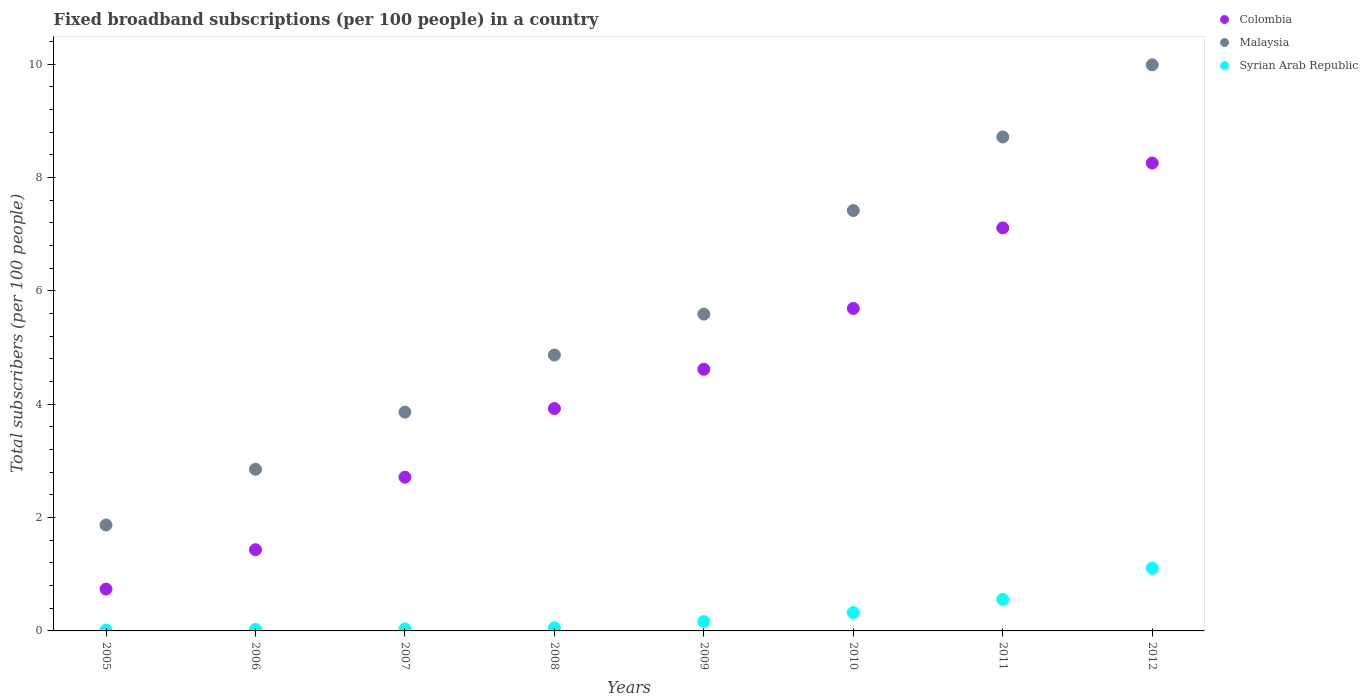How many different coloured dotlines are there?
Make the answer very short. 3. Is the number of dotlines equal to the number of legend labels?
Ensure brevity in your answer.  Yes. What is the number of broadband subscriptions in Syrian Arab Republic in 2011?
Keep it short and to the point. 0.56. Across all years, what is the maximum number of broadband subscriptions in Colombia?
Offer a very short reply. 8.26. Across all years, what is the minimum number of broadband subscriptions in Malaysia?
Make the answer very short. 1.87. In which year was the number of broadband subscriptions in Colombia maximum?
Make the answer very short. 2012. In which year was the number of broadband subscriptions in Syrian Arab Republic minimum?
Provide a succinct answer. 2005. What is the total number of broadband subscriptions in Colombia in the graph?
Offer a very short reply. 34.48. What is the difference between the number of broadband subscriptions in Malaysia in 2007 and that in 2008?
Your response must be concise. -1.01. What is the difference between the number of broadband subscriptions in Colombia in 2009 and the number of broadband subscriptions in Syrian Arab Republic in 2012?
Give a very brief answer. 3.51. What is the average number of broadband subscriptions in Syrian Arab Republic per year?
Offer a very short reply. 0.29. In the year 2007, what is the difference between the number of broadband subscriptions in Colombia and number of broadband subscriptions in Malaysia?
Your answer should be compact. -1.15. In how many years, is the number of broadband subscriptions in Syrian Arab Republic greater than 2.8?
Provide a succinct answer. 0. What is the ratio of the number of broadband subscriptions in Malaysia in 2009 to that in 2012?
Provide a short and direct response. 0.56. Is the number of broadband subscriptions in Colombia in 2007 less than that in 2012?
Ensure brevity in your answer.  Yes. Is the difference between the number of broadband subscriptions in Colombia in 2008 and 2010 greater than the difference between the number of broadband subscriptions in Malaysia in 2008 and 2010?
Provide a short and direct response. Yes. What is the difference between the highest and the second highest number of broadband subscriptions in Syrian Arab Republic?
Your answer should be compact. 0.55. What is the difference between the highest and the lowest number of broadband subscriptions in Syrian Arab Republic?
Keep it short and to the point. 1.09. In how many years, is the number of broadband subscriptions in Colombia greater than the average number of broadband subscriptions in Colombia taken over all years?
Your answer should be very brief. 4. How many years are there in the graph?
Make the answer very short. 8. What is the difference between two consecutive major ticks on the Y-axis?
Offer a terse response. 2. Are the values on the major ticks of Y-axis written in scientific E-notation?
Your answer should be compact. No. Does the graph contain grids?
Provide a succinct answer. No. How are the legend labels stacked?
Give a very brief answer. Vertical. What is the title of the graph?
Your answer should be compact. Fixed broadband subscriptions (per 100 people) in a country. Does "Uzbekistan" appear as one of the legend labels in the graph?
Keep it short and to the point. No. What is the label or title of the X-axis?
Offer a terse response. Years. What is the label or title of the Y-axis?
Give a very brief answer. Total subscribers (per 100 people). What is the Total subscribers (per 100 people) of Colombia in 2005?
Provide a short and direct response. 0.74. What is the Total subscribers (per 100 people) in Malaysia in 2005?
Ensure brevity in your answer.  1.87. What is the Total subscribers (per 100 people) of Syrian Arab Republic in 2005?
Your answer should be very brief. 0.01. What is the Total subscribers (per 100 people) in Colombia in 2006?
Your answer should be very brief. 1.43. What is the Total subscribers (per 100 people) of Malaysia in 2006?
Your answer should be very brief. 2.85. What is the Total subscribers (per 100 people) in Syrian Arab Republic in 2006?
Make the answer very short. 0.03. What is the Total subscribers (per 100 people) of Colombia in 2007?
Provide a short and direct response. 2.71. What is the Total subscribers (per 100 people) of Malaysia in 2007?
Your answer should be compact. 3.86. What is the Total subscribers (per 100 people) of Syrian Arab Republic in 2007?
Provide a succinct answer. 0.04. What is the Total subscribers (per 100 people) of Colombia in 2008?
Offer a terse response. 3.92. What is the Total subscribers (per 100 people) in Malaysia in 2008?
Your answer should be compact. 4.87. What is the Total subscribers (per 100 people) of Syrian Arab Republic in 2008?
Your answer should be very brief. 0.05. What is the Total subscribers (per 100 people) in Colombia in 2009?
Your response must be concise. 4.62. What is the Total subscribers (per 100 people) of Malaysia in 2009?
Provide a succinct answer. 5.59. What is the Total subscribers (per 100 people) in Syrian Arab Republic in 2009?
Provide a succinct answer. 0.16. What is the Total subscribers (per 100 people) of Colombia in 2010?
Ensure brevity in your answer.  5.69. What is the Total subscribers (per 100 people) of Malaysia in 2010?
Your answer should be very brief. 7.42. What is the Total subscribers (per 100 people) in Syrian Arab Republic in 2010?
Give a very brief answer. 0.32. What is the Total subscribers (per 100 people) of Colombia in 2011?
Your answer should be compact. 7.11. What is the Total subscribers (per 100 people) of Malaysia in 2011?
Provide a short and direct response. 8.72. What is the Total subscribers (per 100 people) of Syrian Arab Republic in 2011?
Your answer should be very brief. 0.56. What is the Total subscribers (per 100 people) of Colombia in 2012?
Your response must be concise. 8.26. What is the Total subscribers (per 100 people) in Malaysia in 2012?
Provide a succinct answer. 9.99. What is the Total subscribers (per 100 people) of Syrian Arab Republic in 2012?
Provide a succinct answer. 1.11. Across all years, what is the maximum Total subscribers (per 100 people) of Colombia?
Offer a very short reply. 8.26. Across all years, what is the maximum Total subscribers (per 100 people) in Malaysia?
Your answer should be very brief. 9.99. Across all years, what is the maximum Total subscribers (per 100 people) of Syrian Arab Republic?
Your answer should be compact. 1.11. Across all years, what is the minimum Total subscribers (per 100 people) in Colombia?
Ensure brevity in your answer.  0.74. Across all years, what is the minimum Total subscribers (per 100 people) in Malaysia?
Your answer should be compact. 1.87. Across all years, what is the minimum Total subscribers (per 100 people) in Syrian Arab Republic?
Your response must be concise. 0.01. What is the total Total subscribers (per 100 people) in Colombia in the graph?
Your answer should be very brief. 34.48. What is the total Total subscribers (per 100 people) in Malaysia in the graph?
Provide a short and direct response. 45.17. What is the total Total subscribers (per 100 people) of Syrian Arab Republic in the graph?
Make the answer very short. 2.28. What is the difference between the Total subscribers (per 100 people) in Colombia in 2005 and that in 2006?
Your response must be concise. -0.69. What is the difference between the Total subscribers (per 100 people) of Malaysia in 2005 and that in 2006?
Your answer should be very brief. -0.98. What is the difference between the Total subscribers (per 100 people) of Syrian Arab Republic in 2005 and that in 2006?
Your answer should be very brief. -0.01. What is the difference between the Total subscribers (per 100 people) in Colombia in 2005 and that in 2007?
Provide a short and direct response. -1.97. What is the difference between the Total subscribers (per 100 people) of Malaysia in 2005 and that in 2007?
Your answer should be very brief. -1.99. What is the difference between the Total subscribers (per 100 people) of Syrian Arab Republic in 2005 and that in 2007?
Make the answer very short. -0.02. What is the difference between the Total subscribers (per 100 people) in Colombia in 2005 and that in 2008?
Keep it short and to the point. -3.19. What is the difference between the Total subscribers (per 100 people) of Malaysia in 2005 and that in 2008?
Offer a terse response. -3. What is the difference between the Total subscribers (per 100 people) of Syrian Arab Republic in 2005 and that in 2008?
Ensure brevity in your answer.  -0.04. What is the difference between the Total subscribers (per 100 people) in Colombia in 2005 and that in 2009?
Offer a terse response. -3.88. What is the difference between the Total subscribers (per 100 people) of Malaysia in 2005 and that in 2009?
Your response must be concise. -3.72. What is the difference between the Total subscribers (per 100 people) of Syrian Arab Republic in 2005 and that in 2009?
Provide a short and direct response. -0.15. What is the difference between the Total subscribers (per 100 people) in Colombia in 2005 and that in 2010?
Offer a terse response. -4.95. What is the difference between the Total subscribers (per 100 people) of Malaysia in 2005 and that in 2010?
Offer a very short reply. -5.55. What is the difference between the Total subscribers (per 100 people) in Syrian Arab Republic in 2005 and that in 2010?
Ensure brevity in your answer.  -0.31. What is the difference between the Total subscribers (per 100 people) in Colombia in 2005 and that in 2011?
Make the answer very short. -6.37. What is the difference between the Total subscribers (per 100 people) in Malaysia in 2005 and that in 2011?
Offer a very short reply. -6.85. What is the difference between the Total subscribers (per 100 people) of Syrian Arab Republic in 2005 and that in 2011?
Give a very brief answer. -0.54. What is the difference between the Total subscribers (per 100 people) of Colombia in 2005 and that in 2012?
Your response must be concise. -7.52. What is the difference between the Total subscribers (per 100 people) of Malaysia in 2005 and that in 2012?
Your answer should be very brief. -8.12. What is the difference between the Total subscribers (per 100 people) in Syrian Arab Republic in 2005 and that in 2012?
Your answer should be very brief. -1.09. What is the difference between the Total subscribers (per 100 people) of Colombia in 2006 and that in 2007?
Keep it short and to the point. -1.28. What is the difference between the Total subscribers (per 100 people) of Malaysia in 2006 and that in 2007?
Offer a very short reply. -1.01. What is the difference between the Total subscribers (per 100 people) in Syrian Arab Republic in 2006 and that in 2007?
Your response must be concise. -0.01. What is the difference between the Total subscribers (per 100 people) in Colombia in 2006 and that in 2008?
Provide a short and direct response. -2.49. What is the difference between the Total subscribers (per 100 people) in Malaysia in 2006 and that in 2008?
Your answer should be very brief. -2.02. What is the difference between the Total subscribers (per 100 people) of Syrian Arab Republic in 2006 and that in 2008?
Offer a terse response. -0.03. What is the difference between the Total subscribers (per 100 people) in Colombia in 2006 and that in 2009?
Your answer should be very brief. -3.18. What is the difference between the Total subscribers (per 100 people) in Malaysia in 2006 and that in 2009?
Your answer should be compact. -2.74. What is the difference between the Total subscribers (per 100 people) of Syrian Arab Republic in 2006 and that in 2009?
Offer a terse response. -0.14. What is the difference between the Total subscribers (per 100 people) in Colombia in 2006 and that in 2010?
Keep it short and to the point. -4.26. What is the difference between the Total subscribers (per 100 people) of Malaysia in 2006 and that in 2010?
Your response must be concise. -4.57. What is the difference between the Total subscribers (per 100 people) in Syrian Arab Republic in 2006 and that in 2010?
Your answer should be compact. -0.3. What is the difference between the Total subscribers (per 100 people) of Colombia in 2006 and that in 2011?
Offer a terse response. -5.68. What is the difference between the Total subscribers (per 100 people) of Malaysia in 2006 and that in 2011?
Give a very brief answer. -5.86. What is the difference between the Total subscribers (per 100 people) of Syrian Arab Republic in 2006 and that in 2011?
Your answer should be compact. -0.53. What is the difference between the Total subscribers (per 100 people) in Colombia in 2006 and that in 2012?
Provide a succinct answer. -6.82. What is the difference between the Total subscribers (per 100 people) in Malaysia in 2006 and that in 2012?
Provide a succinct answer. -7.14. What is the difference between the Total subscribers (per 100 people) in Syrian Arab Republic in 2006 and that in 2012?
Your answer should be very brief. -1.08. What is the difference between the Total subscribers (per 100 people) in Colombia in 2007 and that in 2008?
Your answer should be very brief. -1.21. What is the difference between the Total subscribers (per 100 people) in Malaysia in 2007 and that in 2008?
Provide a succinct answer. -1.01. What is the difference between the Total subscribers (per 100 people) in Syrian Arab Republic in 2007 and that in 2008?
Give a very brief answer. -0.02. What is the difference between the Total subscribers (per 100 people) of Colombia in 2007 and that in 2009?
Ensure brevity in your answer.  -1.9. What is the difference between the Total subscribers (per 100 people) of Malaysia in 2007 and that in 2009?
Your response must be concise. -1.73. What is the difference between the Total subscribers (per 100 people) of Syrian Arab Republic in 2007 and that in 2009?
Make the answer very short. -0.13. What is the difference between the Total subscribers (per 100 people) in Colombia in 2007 and that in 2010?
Make the answer very short. -2.98. What is the difference between the Total subscribers (per 100 people) of Malaysia in 2007 and that in 2010?
Make the answer very short. -3.56. What is the difference between the Total subscribers (per 100 people) of Syrian Arab Republic in 2007 and that in 2010?
Offer a terse response. -0.29. What is the difference between the Total subscribers (per 100 people) of Colombia in 2007 and that in 2011?
Offer a terse response. -4.4. What is the difference between the Total subscribers (per 100 people) of Malaysia in 2007 and that in 2011?
Give a very brief answer. -4.86. What is the difference between the Total subscribers (per 100 people) of Syrian Arab Republic in 2007 and that in 2011?
Offer a very short reply. -0.52. What is the difference between the Total subscribers (per 100 people) of Colombia in 2007 and that in 2012?
Ensure brevity in your answer.  -5.54. What is the difference between the Total subscribers (per 100 people) of Malaysia in 2007 and that in 2012?
Provide a succinct answer. -6.13. What is the difference between the Total subscribers (per 100 people) of Syrian Arab Republic in 2007 and that in 2012?
Provide a succinct answer. -1.07. What is the difference between the Total subscribers (per 100 people) in Colombia in 2008 and that in 2009?
Your answer should be compact. -0.69. What is the difference between the Total subscribers (per 100 people) of Malaysia in 2008 and that in 2009?
Give a very brief answer. -0.72. What is the difference between the Total subscribers (per 100 people) of Syrian Arab Republic in 2008 and that in 2009?
Provide a short and direct response. -0.11. What is the difference between the Total subscribers (per 100 people) in Colombia in 2008 and that in 2010?
Offer a very short reply. -1.77. What is the difference between the Total subscribers (per 100 people) in Malaysia in 2008 and that in 2010?
Your response must be concise. -2.55. What is the difference between the Total subscribers (per 100 people) in Syrian Arab Republic in 2008 and that in 2010?
Keep it short and to the point. -0.27. What is the difference between the Total subscribers (per 100 people) of Colombia in 2008 and that in 2011?
Provide a succinct answer. -3.19. What is the difference between the Total subscribers (per 100 people) of Malaysia in 2008 and that in 2011?
Give a very brief answer. -3.85. What is the difference between the Total subscribers (per 100 people) in Syrian Arab Republic in 2008 and that in 2011?
Make the answer very short. -0.5. What is the difference between the Total subscribers (per 100 people) of Colombia in 2008 and that in 2012?
Your answer should be very brief. -4.33. What is the difference between the Total subscribers (per 100 people) of Malaysia in 2008 and that in 2012?
Keep it short and to the point. -5.12. What is the difference between the Total subscribers (per 100 people) in Syrian Arab Republic in 2008 and that in 2012?
Provide a succinct answer. -1.05. What is the difference between the Total subscribers (per 100 people) in Colombia in 2009 and that in 2010?
Offer a terse response. -1.07. What is the difference between the Total subscribers (per 100 people) in Malaysia in 2009 and that in 2010?
Your response must be concise. -1.83. What is the difference between the Total subscribers (per 100 people) of Syrian Arab Republic in 2009 and that in 2010?
Your answer should be very brief. -0.16. What is the difference between the Total subscribers (per 100 people) of Colombia in 2009 and that in 2011?
Your answer should be very brief. -2.49. What is the difference between the Total subscribers (per 100 people) of Malaysia in 2009 and that in 2011?
Provide a succinct answer. -3.13. What is the difference between the Total subscribers (per 100 people) of Syrian Arab Republic in 2009 and that in 2011?
Your response must be concise. -0.39. What is the difference between the Total subscribers (per 100 people) in Colombia in 2009 and that in 2012?
Your answer should be compact. -3.64. What is the difference between the Total subscribers (per 100 people) of Malaysia in 2009 and that in 2012?
Provide a short and direct response. -4.4. What is the difference between the Total subscribers (per 100 people) in Syrian Arab Republic in 2009 and that in 2012?
Provide a succinct answer. -0.94. What is the difference between the Total subscribers (per 100 people) of Colombia in 2010 and that in 2011?
Provide a succinct answer. -1.42. What is the difference between the Total subscribers (per 100 people) in Malaysia in 2010 and that in 2011?
Your response must be concise. -1.3. What is the difference between the Total subscribers (per 100 people) in Syrian Arab Republic in 2010 and that in 2011?
Your answer should be very brief. -0.23. What is the difference between the Total subscribers (per 100 people) in Colombia in 2010 and that in 2012?
Provide a succinct answer. -2.57. What is the difference between the Total subscribers (per 100 people) of Malaysia in 2010 and that in 2012?
Provide a short and direct response. -2.57. What is the difference between the Total subscribers (per 100 people) in Syrian Arab Republic in 2010 and that in 2012?
Offer a very short reply. -0.78. What is the difference between the Total subscribers (per 100 people) of Colombia in 2011 and that in 2012?
Make the answer very short. -1.14. What is the difference between the Total subscribers (per 100 people) of Malaysia in 2011 and that in 2012?
Ensure brevity in your answer.  -1.27. What is the difference between the Total subscribers (per 100 people) in Syrian Arab Republic in 2011 and that in 2012?
Your answer should be compact. -0.55. What is the difference between the Total subscribers (per 100 people) of Colombia in 2005 and the Total subscribers (per 100 people) of Malaysia in 2006?
Ensure brevity in your answer.  -2.11. What is the difference between the Total subscribers (per 100 people) of Colombia in 2005 and the Total subscribers (per 100 people) of Syrian Arab Republic in 2006?
Ensure brevity in your answer.  0.71. What is the difference between the Total subscribers (per 100 people) in Malaysia in 2005 and the Total subscribers (per 100 people) in Syrian Arab Republic in 2006?
Ensure brevity in your answer.  1.84. What is the difference between the Total subscribers (per 100 people) in Colombia in 2005 and the Total subscribers (per 100 people) in Malaysia in 2007?
Ensure brevity in your answer.  -3.12. What is the difference between the Total subscribers (per 100 people) in Colombia in 2005 and the Total subscribers (per 100 people) in Syrian Arab Republic in 2007?
Provide a succinct answer. 0.7. What is the difference between the Total subscribers (per 100 people) in Malaysia in 2005 and the Total subscribers (per 100 people) in Syrian Arab Republic in 2007?
Your response must be concise. 1.83. What is the difference between the Total subscribers (per 100 people) of Colombia in 2005 and the Total subscribers (per 100 people) of Malaysia in 2008?
Make the answer very short. -4.13. What is the difference between the Total subscribers (per 100 people) in Colombia in 2005 and the Total subscribers (per 100 people) in Syrian Arab Republic in 2008?
Offer a very short reply. 0.68. What is the difference between the Total subscribers (per 100 people) of Malaysia in 2005 and the Total subscribers (per 100 people) of Syrian Arab Republic in 2008?
Provide a short and direct response. 1.81. What is the difference between the Total subscribers (per 100 people) in Colombia in 2005 and the Total subscribers (per 100 people) in Malaysia in 2009?
Offer a terse response. -4.85. What is the difference between the Total subscribers (per 100 people) in Colombia in 2005 and the Total subscribers (per 100 people) in Syrian Arab Republic in 2009?
Your answer should be very brief. 0.57. What is the difference between the Total subscribers (per 100 people) of Malaysia in 2005 and the Total subscribers (per 100 people) of Syrian Arab Republic in 2009?
Provide a short and direct response. 1.7. What is the difference between the Total subscribers (per 100 people) of Colombia in 2005 and the Total subscribers (per 100 people) of Malaysia in 2010?
Offer a terse response. -6.68. What is the difference between the Total subscribers (per 100 people) of Colombia in 2005 and the Total subscribers (per 100 people) of Syrian Arab Republic in 2010?
Your response must be concise. 0.41. What is the difference between the Total subscribers (per 100 people) of Malaysia in 2005 and the Total subscribers (per 100 people) of Syrian Arab Republic in 2010?
Keep it short and to the point. 1.55. What is the difference between the Total subscribers (per 100 people) in Colombia in 2005 and the Total subscribers (per 100 people) in Malaysia in 2011?
Your answer should be compact. -7.98. What is the difference between the Total subscribers (per 100 people) in Colombia in 2005 and the Total subscribers (per 100 people) in Syrian Arab Republic in 2011?
Your response must be concise. 0.18. What is the difference between the Total subscribers (per 100 people) in Malaysia in 2005 and the Total subscribers (per 100 people) in Syrian Arab Republic in 2011?
Offer a very short reply. 1.31. What is the difference between the Total subscribers (per 100 people) of Colombia in 2005 and the Total subscribers (per 100 people) of Malaysia in 2012?
Ensure brevity in your answer.  -9.25. What is the difference between the Total subscribers (per 100 people) in Colombia in 2005 and the Total subscribers (per 100 people) in Syrian Arab Republic in 2012?
Keep it short and to the point. -0.37. What is the difference between the Total subscribers (per 100 people) in Malaysia in 2005 and the Total subscribers (per 100 people) in Syrian Arab Republic in 2012?
Offer a terse response. 0.76. What is the difference between the Total subscribers (per 100 people) of Colombia in 2006 and the Total subscribers (per 100 people) of Malaysia in 2007?
Provide a succinct answer. -2.43. What is the difference between the Total subscribers (per 100 people) of Colombia in 2006 and the Total subscribers (per 100 people) of Syrian Arab Republic in 2007?
Offer a terse response. 1.4. What is the difference between the Total subscribers (per 100 people) of Malaysia in 2006 and the Total subscribers (per 100 people) of Syrian Arab Republic in 2007?
Your answer should be compact. 2.82. What is the difference between the Total subscribers (per 100 people) of Colombia in 2006 and the Total subscribers (per 100 people) of Malaysia in 2008?
Your answer should be very brief. -3.44. What is the difference between the Total subscribers (per 100 people) of Colombia in 2006 and the Total subscribers (per 100 people) of Syrian Arab Republic in 2008?
Offer a terse response. 1.38. What is the difference between the Total subscribers (per 100 people) in Malaysia in 2006 and the Total subscribers (per 100 people) in Syrian Arab Republic in 2008?
Ensure brevity in your answer.  2.8. What is the difference between the Total subscribers (per 100 people) in Colombia in 2006 and the Total subscribers (per 100 people) in Malaysia in 2009?
Your answer should be very brief. -4.16. What is the difference between the Total subscribers (per 100 people) in Colombia in 2006 and the Total subscribers (per 100 people) in Syrian Arab Republic in 2009?
Ensure brevity in your answer.  1.27. What is the difference between the Total subscribers (per 100 people) of Malaysia in 2006 and the Total subscribers (per 100 people) of Syrian Arab Republic in 2009?
Your response must be concise. 2.69. What is the difference between the Total subscribers (per 100 people) in Colombia in 2006 and the Total subscribers (per 100 people) in Malaysia in 2010?
Offer a terse response. -5.99. What is the difference between the Total subscribers (per 100 people) in Colombia in 2006 and the Total subscribers (per 100 people) in Syrian Arab Republic in 2010?
Offer a very short reply. 1.11. What is the difference between the Total subscribers (per 100 people) in Malaysia in 2006 and the Total subscribers (per 100 people) in Syrian Arab Republic in 2010?
Give a very brief answer. 2.53. What is the difference between the Total subscribers (per 100 people) in Colombia in 2006 and the Total subscribers (per 100 people) in Malaysia in 2011?
Make the answer very short. -7.28. What is the difference between the Total subscribers (per 100 people) in Colombia in 2006 and the Total subscribers (per 100 people) in Syrian Arab Republic in 2011?
Provide a succinct answer. 0.88. What is the difference between the Total subscribers (per 100 people) of Malaysia in 2006 and the Total subscribers (per 100 people) of Syrian Arab Republic in 2011?
Ensure brevity in your answer.  2.3. What is the difference between the Total subscribers (per 100 people) of Colombia in 2006 and the Total subscribers (per 100 people) of Malaysia in 2012?
Your answer should be very brief. -8.56. What is the difference between the Total subscribers (per 100 people) of Colombia in 2006 and the Total subscribers (per 100 people) of Syrian Arab Republic in 2012?
Offer a terse response. 0.33. What is the difference between the Total subscribers (per 100 people) of Malaysia in 2006 and the Total subscribers (per 100 people) of Syrian Arab Republic in 2012?
Keep it short and to the point. 1.75. What is the difference between the Total subscribers (per 100 people) in Colombia in 2007 and the Total subscribers (per 100 people) in Malaysia in 2008?
Make the answer very short. -2.16. What is the difference between the Total subscribers (per 100 people) in Colombia in 2007 and the Total subscribers (per 100 people) in Syrian Arab Republic in 2008?
Your answer should be compact. 2.66. What is the difference between the Total subscribers (per 100 people) in Malaysia in 2007 and the Total subscribers (per 100 people) in Syrian Arab Republic in 2008?
Offer a very short reply. 3.81. What is the difference between the Total subscribers (per 100 people) of Colombia in 2007 and the Total subscribers (per 100 people) of Malaysia in 2009?
Provide a succinct answer. -2.88. What is the difference between the Total subscribers (per 100 people) in Colombia in 2007 and the Total subscribers (per 100 people) in Syrian Arab Republic in 2009?
Your answer should be compact. 2.55. What is the difference between the Total subscribers (per 100 people) in Malaysia in 2007 and the Total subscribers (per 100 people) in Syrian Arab Republic in 2009?
Your answer should be very brief. 3.7. What is the difference between the Total subscribers (per 100 people) of Colombia in 2007 and the Total subscribers (per 100 people) of Malaysia in 2010?
Make the answer very short. -4.71. What is the difference between the Total subscribers (per 100 people) of Colombia in 2007 and the Total subscribers (per 100 people) of Syrian Arab Republic in 2010?
Offer a very short reply. 2.39. What is the difference between the Total subscribers (per 100 people) of Malaysia in 2007 and the Total subscribers (per 100 people) of Syrian Arab Republic in 2010?
Offer a very short reply. 3.54. What is the difference between the Total subscribers (per 100 people) in Colombia in 2007 and the Total subscribers (per 100 people) in Malaysia in 2011?
Provide a succinct answer. -6. What is the difference between the Total subscribers (per 100 people) of Colombia in 2007 and the Total subscribers (per 100 people) of Syrian Arab Republic in 2011?
Your answer should be compact. 2.16. What is the difference between the Total subscribers (per 100 people) in Malaysia in 2007 and the Total subscribers (per 100 people) in Syrian Arab Republic in 2011?
Make the answer very short. 3.3. What is the difference between the Total subscribers (per 100 people) of Colombia in 2007 and the Total subscribers (per 100 people) of Malaysia in 2012?
Provide a short and direct response. -7.28. What is the difference between the Total subscribers (per 100 people) of Colombia in 2007 and the Total subscribers (per 100 people) of Syrian Arab Republic in 2012?
Provide a short and direct response. 1.61. What is the difference between the Total subscribers (per 100 people) in Malaysia in 2007 and the Total subscribers (per 100 people) in Syrian Arab Republic in 2012?
Your response must be concise. 2.75. What is the difference between the Total subscribers (per 100 people) in Colombia in 2008 and the Total subscribers (per 100 people) in Malaysia in 2009?
Your answer should be compact. -1.67. What is the difference between the Total subscribers (per 100 people) in Colombia in 2008 and the Total subscribers (per 100 people) in Syrian Arab Republic in 2009?
Keep it short and to the point. 3.76. What is the difference between the Total subscribers (per 100 people) in Malaysia in 2008 and the Total subscribers (per 100 people) in Syrian Arab Republic in 2009?
Give a very brief answer. 4.7. What is the difference between the Total subscribers (per 100 people) of Colombia in 2008 and the Total subscribers (per 100 people) of Malaysia in 2010?
Your answer should be very brief. -3.49. What is the difference between the Total subscribers (per 100 people) in Colombia in 2008 and the Total subscribers (per 100 people) in Syrian Arab Republic in 2010?
Ensure brevity in your answer.  3.6. What is the difference between the Total subscribers (per 100 people) in Malaysia in 2008 and the Total subscribers (per 100 people) in Syrian Arab Republic in 2010?
Give a very brief answer. 4.54. What is the difference between the Total subscribers (per 100 people) in Colombia in 2008 and the Total subscribers (per 100 people) in Malaysia in 2011?
Your answer should be compact. -4.79. What is the difference between the Total subscribers (per 100 people) of Colombia in 2008 and the Total subscribers (per 100 people) of Syrian Arab Republic in 2011?
Your answer should be compact. 3.37. What is the difference between the Total subscribers (per 100 people) of Malaysia in 2008 and the Total subscribers (per 100 people) of Syrian Arab Republic in 2011?
Ensure brevity in your answer.  4.31. What is the difference between the Total subscribers (per 100 people) in Colombia in 2008 and the Total subscribers (per 100 people) in Malaysia in 2012?
Offer a very short reply. -6.06. What is the difference between the Total subscribers (per 100 people) of Colombia in 2008 and the Total subscribers (per 100 people) of Syrian Arab Republic in 2012?
Provide a succinct answer. 2.82. What is the difference between the Total subscribers (per 100 people) of Malaysia in 2008 and the Total subscribers (per 100 people) of Syrian Arab Republic in 2012?
Your answer should be compact. 3.76. What is the difference between the Total subscribers (per 100 people) in Colombia in 2009 and the Total subscribers (per 100 people) in Malaysia in 2010?
Your response must be concise. -2.8. What is the difference between the Total subscribers (per 100 people) in Colombia in 2009 and the Total subscribers (per 100 people) in Syrian Arab Republic in 2010?
Offer a terse response. 4.29. What is the difference between the Total subscribers (per 100 people) of Malaysia in 2009 and the Total subscribers (per 100 people) of Syrian Arab Republic in 2010?
Ensure brevity in your answer.  5.27. What is the difference between the Total subscribers (per 100 people) in Colombia in 2009 and the Total subscribers (per 100 people) in Malaysia in 2011?
Make the answer very short. -4.1. What is the difference between the Total subscribers (per 100 people) of Colombia in 2009 and the Total subscribers (per 100 people) of Syrian Arab Republic in 2011?
Offer a very short reply. 4.06. What is the difference between the Total subscribers (per 100 people) of Malaysia in 2009 and the Total subscribers (per 100 people) of Syrian Arab Republic in 2011?
Ensure brevity in your answer.  5.03. What is the difference between the Total subscribers (per 100 people) of Colombia in 2009 and the Total subscribers (per 100 people) of Malaysia in 2012?
Keep it short and to the point. -5.37. What is the difference between the Total subscribers (per 100 people) of Colombia in 2009 and the Total subscribers (per 100 people) of Syrian Arab Republic in 2012?
Ensure brevity in your answer.  3.51. What is the difference between the Total subscribers (per 100 people) in Malaysia in 2009 and the Total subscribers (per 100 people) in Syrian Arab Republic in 2012?
Provide a short and direct response. 4.48. What is the difference between the Total subscribers (per 100 people) of Colombia in 2010 and the Total subscribers (per 100 people) of Malaysia in 2011?
Provide a short and direct response. -3.03. What is the difference between the Total subscribers (per 100 people) in Colombia in 2010 and the Total subscribers (per 100 people) in Syrian Arab Republic in 2011?
Provide a succinct answer. 5.13. What is the difference between the Total subscribers (per 100 people) of Malaysia in 2010 and the Total subscribers (per 100 people) of Syrian Arab Republic in 2011?
Your answer should be very brief. 6.86. What is the difference between the Total subscribers (per 100 people) in Colombia in 2010 and the Total subscribers (per 100 people) in Malaysia in 2012?
Your answer should be compact. -4.3. What is the difference between the Total subscribers (per 100 people) in Colombia in 2010 and the Total subscribers (per 100 people) in Syrian Arab Republic in 2012?
Your response must be concise. 4.58. What is the difference between the Total subscribers (per 100 people) in Malaysia in 2010 and the Total subscribers (per 100 people) in Syrian Arab Republic in 2012?
Offer a very short reply. 6.31. What is the difference between the Total subscribers (per 100 people) of Colombia in 2011 and the Total subscribers (per 100 people) of Malaysia in 2012?
Provide a short and direct response. -2.88. What is the difference between the Total subscribers (per 100 people) in Colombia in 2011 and the Total subscribers (per 100 people) in Syrian Arab Republic in 2012?
Your response must be concise. 6.01. What is the difference between the Total subscribers (per 100 people) of Malaysia in 2011 and the Total subscribers (per 100 people) of Syrian Arab Republic in 2012?
Your answer should be very brief. 7.61. What is the average Total subscribers (per 100 people) in Colombia per year?
Offer a very short reply. 4.31. What is the average Total subscribers (per 100 people) of Malaysia per year?
Give a very brief answer. 5.65. What is the average Total subscribers (per 100 people) in Syrian Arab Republic per year?
Your answer should be very brief. 0.29. In the year 2005, what is the difference between the Total subscribers (per 100 people) in Colombia and Total subscribers (per 100 people) in Malaysia?
Keep it short and to the point. -1.13. In the year 2005, what is the difference between the Total subscribers (per 100 people) of Colombia and Total subscribers (per 100 people) of Syrian Arab Republic?
Provide a succinct answer. 0.72. In the year 2005, what is the difference between the Total subscribers (per 100 people) in Malaysia and Total subscribers (per 100 people) in Syrian Arab Republic?
Keep it short and to the point. 1.85. In the year 2006, what is the difference between the Total subscribers (per 100 people) of Colombia and Total subscribers (per 100 people) of Malaysia?
Provide a short and direct response. -1.42. In the year 2006, what is the difference between the Total subscribers (per 100 people) in Colombia and Total subscribers (per 100 people) in Syrian Arab Republic?
Provide a succinct answer. 1.4. In the year 2006, what is the difference between the Total subscribers (per 100 people) of Malaysia and Total subscribers (per 100 people) of Syrian Arab Republic?
Provide a succinct answer. 2.82. In the year 2007, what is the difference between the Total subscribers (per 100 people) in Colombia and Total subscribers (per 100 people) in Malaysia?
Your response must be concise. -1.15. In the year 2007, what is the difference between the Total subscribers (per 100 people) of Colombia and Total subscribers (per 100 people) of Syrian Arab Republic?
Make the answer very short. 2.68. In the year 2007, what is the difference between the Total subscribers (per 100 people) in Malaysia and Total subscribers (per 100 people) in Syrian Arab Republic?
Ensure brevity in your answer.  3.83. In the year 2008, what is the difference between the Total subscribers (per 100 people) in Colombia and Total subscribers (per 100 people) in Malaysia?
Offer a very short reply. -0.94. In the year 2008, what is the difference between the Total subscribers (per 100 people) of Colombia and Total subscribers (per 100 people) of Syrian Arab Republic?
Provide a short and direct response. 3.87. In the year 2008, what is the difference between the Total subscribers (per 100 people) of Malaysia and Total subscribers (per 100 people) of Syrian Arab Republic?
Offer a very short reply. 4.81. In the year 2009, what is the difference between the Total subscribers (per 100 people) of Colombia and Total subscribers (per 100 people) of Malaysia?
Ensure brevity in your answer.  -0.97. In the year 2009, what is the difference between the Total subscribers (per 100 people) in Colombia and Total subscribers (per 100 people) in Syrian Arab Republic?
Provide a short and direct response. 4.45. In the year 2009, what is the difference between the Total subscribers (per 100 people) of Malaysia and Total subscribers (per 100 people) of Syrian Arab Republic?
Your answer should be very brief. 5.43. In the year 2010, what is the difference between the Total subscribers (per 100 people) in Colombia and Total subscribers (per 100 people) in Malaysia?
Make the answer very short. -1.73. In the year 2010, what is the difference between the Total subscribers (per 100 people) in Colombia and Total subscribers (per 100 people) in Syrian Arab Republic?
Give a very brief answer. 5.37. In the year 2010, what is the difference between the Total subscribers (per 100 people) of Malaysia and Total subscribers (per 100 people) of Syrian Arab Republic?
Offer a terse response. 7.09. In the year 2011, what is the difference between the Total subscribers (per 100 people) in Colombia and Total subscribers (per 100 people) in Malaysia?
Keep it short and to the point. -1.6. In the year 2011, what is the difference between the Total subscribers (per 100 people) in Colombia and Total subscribers (per 100 people) in Syrian Arab Republic?
Give a very brief answer. 6.56. In the year 2011, what is the difference between the Total subscribers (per 100 people) of Malaysia and Total subscribers (per 100 people) of Syrian Arab Republic?
Provide a succinct answer. 8.16. In the year 2012, what is the difference between the Total subscribers (per 100 people) of Colombia and Total subscribers (per 100 people) of Malaysia?
Keep it short and to the point. -1.73. In the year 2012, what is the difference between the Total subscribers (per 100 people) in Colombia and Total subscribers (per 100 people) in Syrian Arab Republic?
Make the answer very short. 7.15. In the year 2012, what is the difference between the Total subscribers (per 100 people) of Malaysia and Total subscribers (per 100 people) of Syrian Arab Republic?
Give a very brief answer. 8.88. What is the ratio of the Total subscribers (per 100 people) in Colombia in 2005 to that in 2006?
Your answer should be compact. 0.52. What is the ratio of the Total subscribers (per 100 people) of Malaysia in 2005 to that in 2006?
Give a very brief answer. 0.66. What is the ratio of the Total subscribers (per 100 people) in Syrian Arab Republic in 2005 to that in 2006?
Ensure brevity in your answer.  0.54. What is the ratio of the Total subscribers (per 100 people) of Colombia in 2005 to that in 2007?
Give a very brief answer. 0.27. What is the ratio of the Total subscribers (per 100 people) in Malaysia in 2005 to that in 2007?
Offer a very short reply. 0.48. What is the ratio of the Total subscribers (per 100 people) of Syrian Arab Republic in 2005 to that in 2007?
Offer a terse response. 0.42. What is the ratio of the Total subscribers (per 100 people) in Colombia in 2005 to that in 2008?
Give a very brief answer. 0.19. What is the ratio of the Total subscribers (per 100 people) of Malaysia in 2005 to that in 2008?
Provide a succinct answer. 0.38. What is the ratio of the Total subscribers (per 100 people) in Syrian Arab Republic in 2005 to that in 2008?
Give a very brief answer. 0.27. What is the ratio of the Total subscribers (per 100 people) in Colombia in 2005 to that in 2009?
Make the answer very short. 0.16. What is the ratio of the Total subscribers (per 100 people) in Malaysia in 2005 to that in 2009?
Provide a short and direct response. 0.33. What is the ratio of the Total subscribers (per 100 people) of Syrian Arab Republic in 2005 to that in 2009?
Your answer should be compact. 0.09. What is the ratio of the Total subscribers (per 100 people) of Colombia in 2005 to that in 2010?
Ensure brevity in your answer.  0.13. What is the ratio of the Total subscribers (per 100 people) in Malaysia in 2005 to that in 2010?
Offer a very short reply. 0.25. What is the ratio of the Total subscribers (per 100 people) of Syrian Arab Republic in 2005 to that in 2010?
Provide a succinct answer. 0.05. What is the ratio of the Total subscribers (per 100 people) of Colombia in 2005 to that in 2011?
Your response must be concise. 0.1. What is the ratio of the Total subscribers (per 100 people) in Malaysia in 2005 to that in 2011?
Make the answer very short. 0.21. What is the ratio of the Total subscribers (per 100 people) in Syrian Arab Republic in 2005 to that in 2011?
Offer a terse response. 0.03. What is the ratio of the Total subscribers (per 100 people) of Colombia in 2005 to that in 2012?
Keep it short and to the point. 0.09. What is the ratio of the Total subscribers (per 100 people) of Malaysia in 2005 to that in 2012?
Offer a terse response. 0.19. What is the ratio of the Total subscribers (per 100 people) in Syrian Arab Republic in 2005 to that in 2012?
Offer a very short reply. 0.01. What is the ratio of the Total subscribers (per 100 people) of Colombia in 2006 to that in 2007?
Provide a succinct answer. 0.53. What is the ratio of the Total subscribers (per 100 people) in Malaysia in 2006 to that in 2007?
Offer a terse response. 0.74. What is the ratio of the Total subscribers (per 100 people) of Syrian Arab Republic in 2006 to that in 2007?
Your answer should be very brief. 0.78. What is the ratio of the Total subscribers (per 100 people) of Colombia in 2006 to that in 2008?
Your answer should be compact. 0.36. What is the ratio of the Total subscribers (per 100 people) in Malaysia in 2006 to that in 2008?
Your response must be concise. 0.59. What is the ratio of the Total subscribers (per 100 people) of Syrian Arab Republic in 2006 to that in 2008?
Your answer should be very brief. 0.51. What is the ratio of the Total subscribers (per 100 people) in Colombia in 2006 to that in 2009?
Offer a very short reply. 0.31. What is the ratio of the Total subscribers (per 100 people) in Malaysia in 2006 to that in 2009?
Keep it short and to the point. 0.51. What is the ratio of the Total subscribers (per 100 people) in Syrian Arab Republic in 2006 to that in 2009?
Offer a terse response. 0.17. What is the ratio of the Total subscribers (per 100 people) of Colombia in 2006 to that in 2010?
Offer a very short reply. 0.25. What is the ratio of the Total subscribers (per 100 people) in Malaysia in 2006 to that in 2010?
Keep it short and to the point. 0.38. What is the ratio of the Total subscribers (per 100 people) in Syrian Arab Republic in 2006 to that in 2010?
Provide a short and direct response. 0.09. What is the ratio of the Total subscribers (per 100 people) of Colombia in 2006 to that in 2011?
Ensure brevity in your answer.  0.2. What is the ratio of the Total subscribers (per 100 people) of Malaysia in 2006 to that in 2011?
Your response must be concise. 0.33. What is the ratio of the Total subscribers (per 100 people) of Syrian Arab Republic in 2006 to that in 2011?
Your answer should be very brief. 0.05. What is the ratio of the Total subscribers (per 100 people) of Colombia in 2006 to that in 2012?
Provide a succinct answer. 0.17. What is the ratio of the Total subscribers (per 100 people) of Malaysia in 2006 to that in 2012?
Give a very brief answer. 0.29. What is the ratio of the Total subscribers (per 100 people) in Syrian Arab Republic in 2006 to that in 2012?
Offer a terse response. 0.03. What is the ratio of the Total subscribers (per 100 people) of Colombia in 2007 to that in 2008?
Make the answer very short. 0.69. What is the ratio of the Total subscribers (per 100 people) in Malaysia in 2007 to that in 2008?
Your answer should be compact. 0.79. What is the ratio of the Total subscribers (per 100 people) of Syrian Arab Republic in 2007 to that in 2008?
Provide a succinct answer. 0.65. What is the ratio of the Total subscribers (per 100 people) in Colombia in 2007 to that in 2009?
Your answer should be compact. 0.59. What is the ratio of the Total subscribers (per 100 people) in Malaysia in 2007 to that in 2009?
Offer a very short reply. 0.69. What is the ratio of the Total subscribers (per 100 people) in Syrian Arab Republic in 2007 to that in 2009?
Your answer should be compact. 0.22. What is the ratio of the Total subscribers (per 100 people) in Colombia in 2007 to that in 2010?
Keep it short and to the point. 0.48. What is the ratio of the Total subscribers (per 100 people) in Malaysia in 2007 to that in 2010?
Your response must be concise. 0.52. What is the ratio of the Total subscribers (per 100 people) of Syrian Arab Republic in 2007 to that in 2010?
Keep it short and to the point. 0.11. What is the ratio of the Total subscribers (per 100 people) in Colombia in 2007 to that in 2011?
Provide a succinct answer. 0.38. What is the ratio of the Total subscribers (per 100 people) in Malaysia in 2007 to that in 2011?
Ensure brevity in your answer.  0.44. What is the ratio of the Total subscribers (per 100 people) of Syrian Arab Republic in 2007 to that in 2011?
Your answer should be compact. 0.06. What is the ratio of the Total subscribers (per 100 people) in Colombia in 2007 to that in 2012?
Offer a very short reply. 0.33. What is the ratio of the Total subscribers (per 100 people) of Malaysia in 2007 to that in 2012?
Offer a terse response. 0.39. What is the ratio of the Total subscribers (per 100 people) in Syrian Arab Republic in 2007 to that in 2012?
Make the answer very short. 0.03. What is the ratio of the Total subscribers (per 100 people) of Colombia in 2008 to that in 2009?
Keep it short and to the point. 0.85. What is the ratio of the Total subscribers (per 100 people) of Malaysia in 2008 to that in 2009?
Provide a succinct answer. 0.87. What is the ratio of the Total subscribers (per 100 people) of Syrian Arab Republic in 2008 to that in 2009?
Your answer should be very brief. 0.33. What is the ratio of the Total subscribers (per 100 people) in Colombia in 2008 to that in 2010?
Offer a very short reply. 0.69. What is the ratio of the Total subscribers (per 100 people) of Malaysia in 2008 to that in 2010?
Your answer should be very brief. 0.66. What is the ratio of the Total subscribers (per 100 people) of Syrian Arab Republic in 2008 to that in 2010?
Your response must be concise. 0.17. What is the ratio of the Total subscribers (per 100 people) of Colombia in 2008 to that in 2011?
Provide a short and direct response. 0.55. What is the ratio of the Total subscribers (per 100 people) in Malaysia in 2008 to that in 2011?
Give a very brief answer. 0.56. What is the ratio of the Total subscribers (per 100 people) of Syrian Arab Republic in 2008 to that in 2011?
Provide a succinct answer. 0.1. What is the ratio of the Total subscribers (per 100 people) in Colombia in 2008 to that in 2012?
Provide a succinct answer. 0.48. What is the ratio of the Total subscribers (per 100 people) of Malaysia in 2008 to that in 2012?
Offer a very short reply. 0.49. What is the ratio of the Total subscribers (per 100 people) in Syrian Arab Republic in 2008 to that in 2012?
Offer a terse response. 0.05. What is the ratio of the Total subscribers (per 100 people) in Colombia in 2009 to that in 2010?
Offer a terse response. 0.81. What is the ratio of the Total subscribers (per 100 people) in Malaysia in 2009 to that in 2010?
Ensure brevity in your answer.  0.75. What is the ratio of the Total subscribers (per 100 people) of Syrian Arab Republic in 2009 to that in 2010?
Make the answer very short. 0.51. What is the ratio of the Total subscribers (per 100 people) in Colombia in 2009 to that in 2011?
Make the answer very short. 0.65. What is the ratio of the Total subscribers (per 100 people) in Malaysia in 2009 to that in 2011?
Make the answer very short. 0.64. What is the ratio of the Total subscribers (per 100 people) of Syrian Arab Republic in 2009 to that in 2011?
Your answer should be very brief. 0.3. What is the ratio of the Total subscribers (per 100 people) of Colombia in 2009 to that in 2012?
Offer a terse response. 0.56. What is the ratio of the Total subscribers (per 100 people) of Malaysia in 2009 to that in 2012?
Your answer should be compact. 0.56. What is the ratio of the Total subscribers (per 100 people) of Syrian Arab Republic in 2009 to that in 2012?
Offer a very short reply. 0.15. What is the ratio of the Total subscribers (per 100 people) of Colombia in 2010 to that in 2011?
Your response must be concise. 0.8. What is the ratio of the Total subscribers (per 100 people) of Malaysia in 2010 to that in 2011?
Keep it short and to the point. 0.85. What is the ratio of the Total subscribers (per 100 people) of Syrian Arab Republic in 2010 to that in 2011?
Offer a terse response. 0.58. What is the ratio of the Total subscribers (per 100 people) of Colombia in 2010 to that in 2012?
Make the answer very short. 0.69. What is the ratio of the Total subscribers (per 100 people) in Malaysia in 2010 to that in 2012?
Your answer should be compact. 0.74. What is the ratio of the Total subscribers (per 100 people) of Syrian Arab Republic in 2010 to that in 2012?
Your answer should be very brief. 0.29. What is the ratio of the Total subscribers (per 100 people) of Colombia in 2011 to that in 2012?
Give a very brief answer. 0.86. What is the ratio of the Total subscribers (per 100 people) of Malaysia in 2011 to that in 2012?
Offer a terse response. 0.87. What is the ratio of the Total subscribers (per 100 people) of Syrian Arab Republic in 2011 to that in 2012?
Provide a succinct answer. 0.5. What is the difference between the highest and the second highest Total subscribers (per 100 people) of Colombia?
Your answer should be very brief. 1.14. What is the difference between the highest and the second highest Total subscribers (per 100 people) in Malaysia?
Provide a short and direct response. 1.27. What is the difference between the highest and the second highest Total subscribers (per 100 people) of Syrian Arab Republic?
Your answer should be compact. 0.55. What is the difference between the highest and the lowest Total subscribers (per 100 people) in Colombia?
Provide a short and direct response. 7.52. What is the difference between the highest and the lowest Total subscribers (per 100 people) of Malaysia?
Your answer should be very brief. 8.12. What is the difference between the highest and the lowest Total subscribers (per 100 people) in Syrian Arab Republic?
Provide a short and direct response. 1.09. 